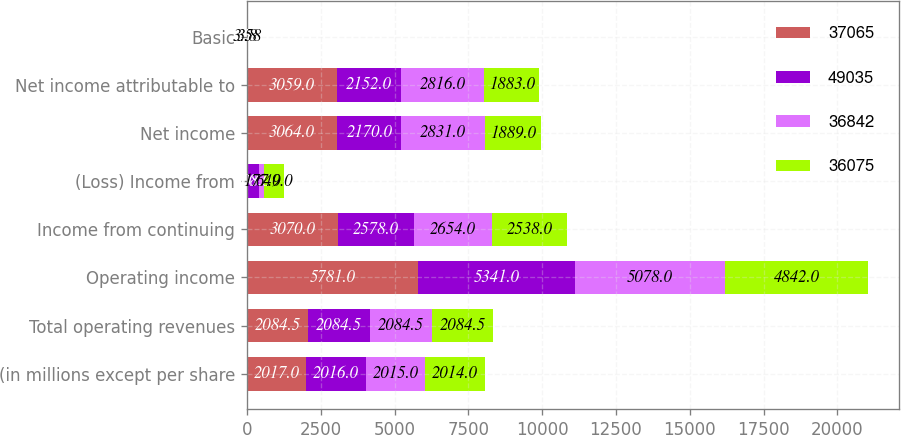<chart> <loc_0><loc_0><loc_500><loc_500><stacked_bar_chart><ecel><fcel>(in millions except per share<fcel>Total operating revenues<fcel>Operating income<fcel>Income from continuing<fcel>(Loss) Income from<fcel>Net income<fcel>Net income attributable to<fcel>Basic<nl><fcel>37065<fcel>2017<fcel>2084.5<fcel>5781<fcel>3070<fcel>6<fcel>3064<fcel>3059<fcel>4.37<nl><fcel>49035<fcel>2016<fcel>2084.5<fcel>5341<fcel>2578<fcel>408<fcel>2170<fcel>2152<fcel>3.71<nl><fcel>36842<fcel>2015<fcel>2084.5<fcel>5078<fcel>2654<fcel>177<fcel>2831<fcel>2816<fcel>3.8<nl><fcel>36075<fcel>2014<fcel>2084.5<fcel>4842<fcel>2538<fcel>649<fcel>1889<fcel>1883<fcel>3.58<nl></chart> 